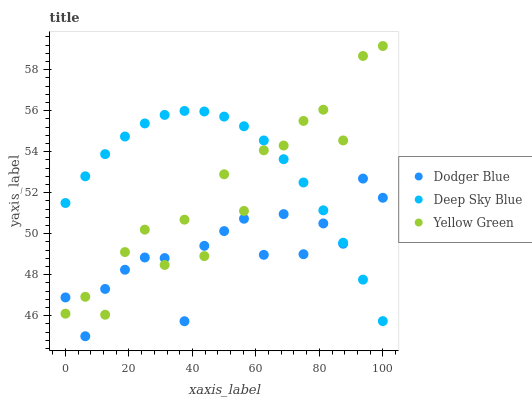Does Dodger Blue have the minimum area under the curve?
Answer yes or no. Yes. Does Deep Sky Blue have the maximum area under the curve?
Answer yes or no. Yes. Does Yellow Green have the minimum area under the curve?
Answer yes or no. No. Does Yellow Green have the maximum area under the curve?
Answer yes or no. No. Is Deep Sky Blue the smoothest?
Answer yes or no. Yes. Is Yellow Green the roughest?
Answer yes or no. Yes. Is Yellow Green the smoothest?
Answer yes or no. No. Is Deep Sky Blue the roughest?
Answer yes or no. No. Does Dodger Blue have the lowest value?
Answer yes or no. Yes. Does Deep Sky Blue have the lowest value?
Answer yes or no. No. Does Yellow Green have the highest value?
Answer yes or no. Yes. Does Deep Sky Blue have the highest value?
Answer yes or no. No. Does Yellow Green intersect Deep Sky Blue?
Answer yes or no. Yes. Is Yellow Green less than Deep Sky Blue?
Answer yes or no. No. Is Yellow Green greater than Deep Sky Blue?
Answer yes or no. No. 